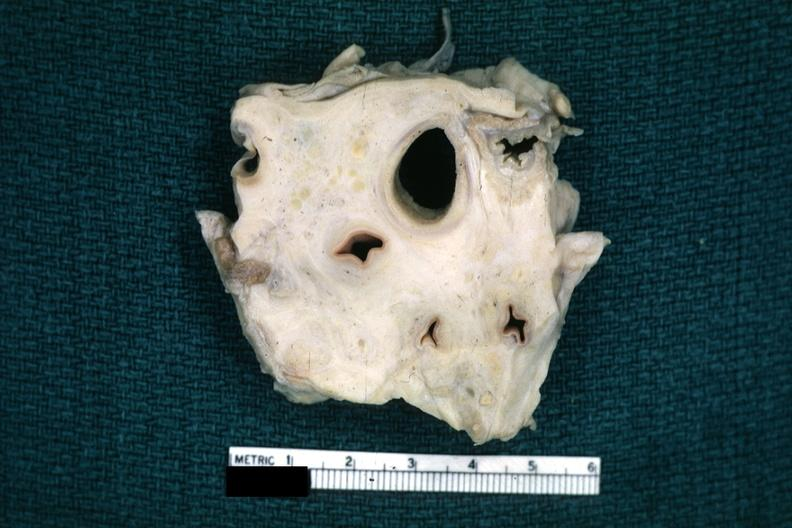where is this?
Answer the question using a single word or phrase. Thorax 